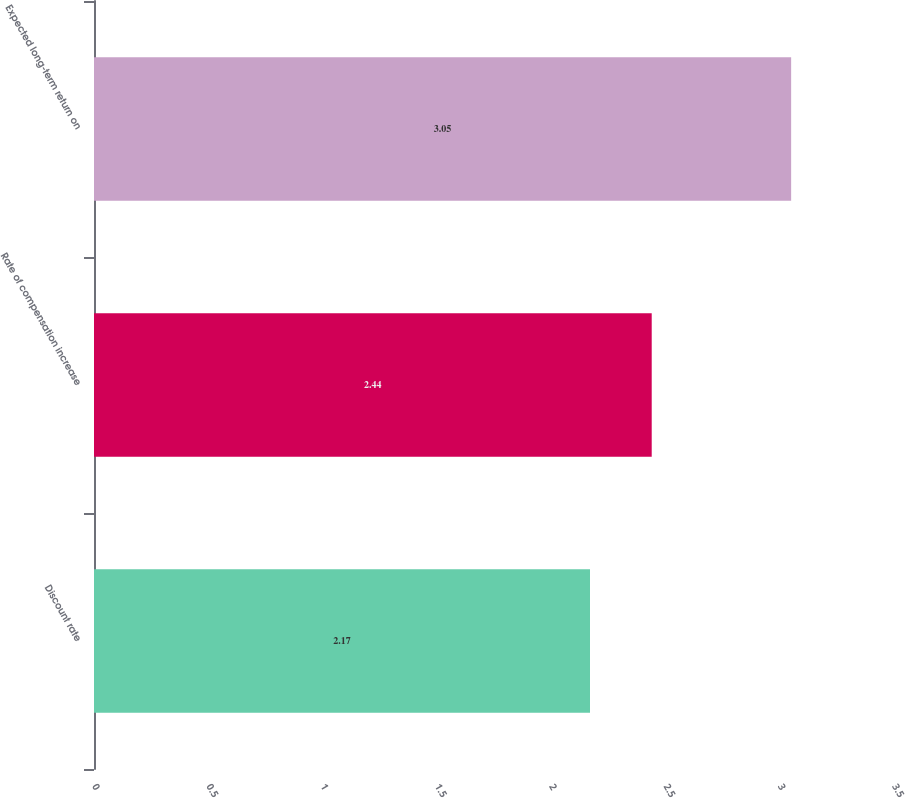Convert chart. <chart><loc_0><loc_0><loc_500><loc_500><bar_chart><fcel>Discount rate<fcel>Rate of compensation increase<fcel>Expected long-term return on<nl><fcel>2.17<fcel>2.44<fcel>3.05<nl></chart> 